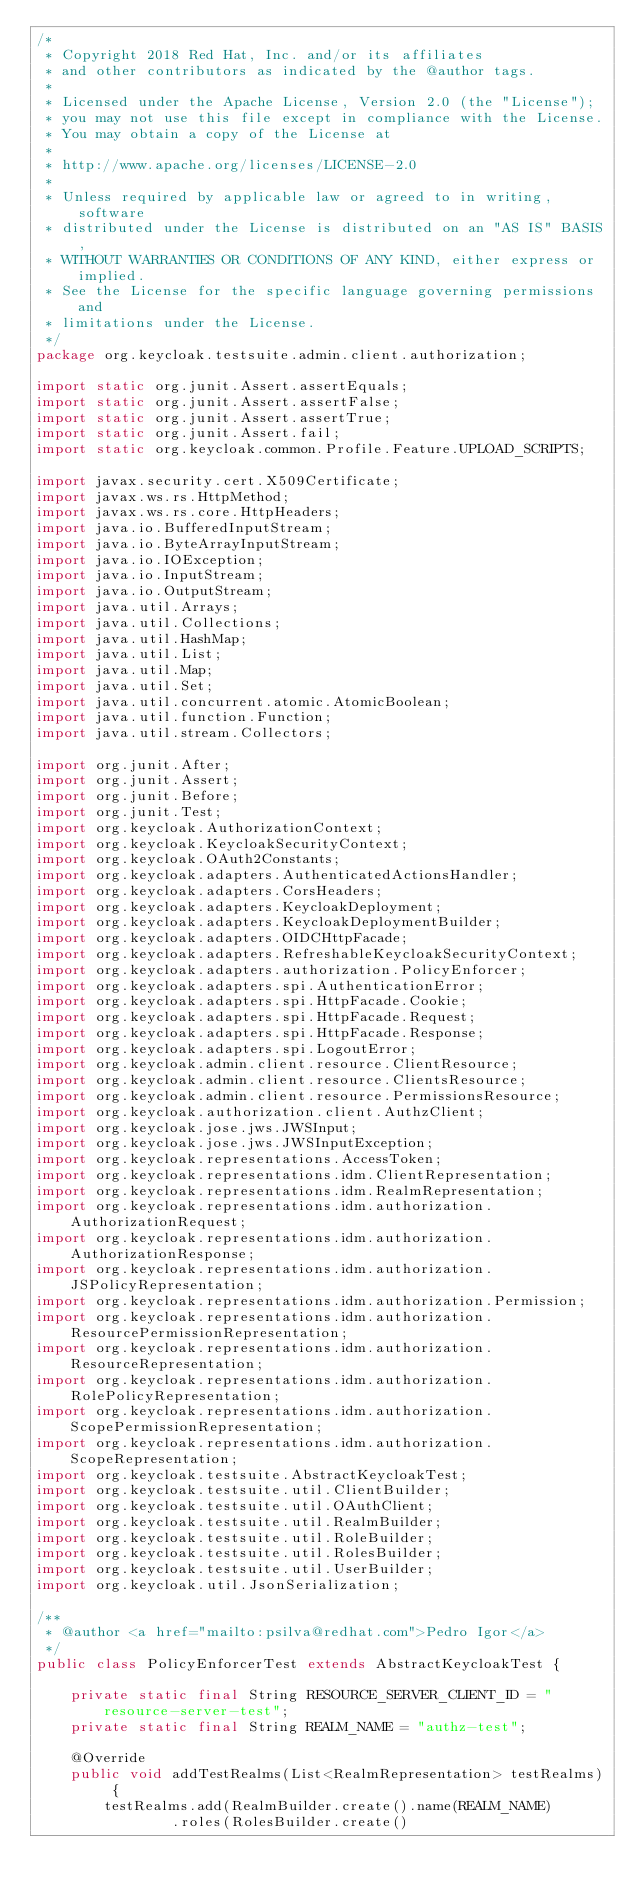Convert code to text. <code><loc_0><loc_0><loc_500><loc_500><_Java_>/*
 * Copyright 2018 Red Hat, Inc. and/or its affiliates
 * and other contributors as indicated by the @author tags.
 *
 * Licensed under the Apache License, Version 2.0 (the "License");
 * you may not use this file except in compliance with the License.
 * You may obtain a copy of the License at
 *
 * http://www.apache.org/licenses/LICENSE-2.0
 *
 * Unless required by applicable law or agreed to in writing, software
 * distributed under the License is distributed on an "AS IS" BASIS,
 * WITHOUT WARRANTIES OR CONDITIONS OF ANY KIND, either express or implied.
 * See the License for the specific language governing permissions and
 * limitations under the License.
 */
package org.keycloak.testsuite.admin.client.authorization;

import static org.junit.Assert.assertEquals;
import static org.junit.Assert.assertFalse;
import static org.junit.Assert.assertTrue;
import static org.junit.Assert.fail;
import static org.keycloak.common.Profile.Feature.UPLOAD_SCRIPTS;

import javax.security.cert.X509Certificate;
import javax.ws.rs.HttpMethod;
import javax.ws.rs.core.HttpHeaders;
import java.io.BufferedInputStream;
import java.io.ByteArrayInputStream;
import java.io.IOException;
import java.io.InputStream;
import java.io.OutputStream;
import java.util.Arrays;
import java.util.Collections;
import java.util.HashMap;
import java.util.List;
import java.util.Map;
import java.util.Set;
import java.util.concurrent.atomic.AtomicBoolean;
import java.util.function.Function;
import java.util.stream.Collectors;

import org.junit.After;
import org.junit.Assert;
import org.junit.Before;
import org.junit.Test;
import org.keycloak.AuthorizationContext;
import org.keycloak.KeycloakSecurityContext;
import org.keycloak.OAuth2Constants;
import org.keycloak.adapters.AuthenticatedActionsHandler;
import org.keycloak.adapters.CorsHeaders;
import org.keycloak.adapters.KeycloakDeployment;
import org.keycloak.adapters.KeycloakDeploymentBuilder;
import org.keycloak.adapters.OIDCHttpFacade;
import org.keycloak.adapters.RefreshableKeycloakSecurityContext;
import org.keycloak.adapters.authorization.PolicyEnforcer;
import org.keycloak.adapters.spi.AuthenticationError;
import org.keycloak.adapters.spi.HttpFacade.Cookie;
import org.keycloak.adapters.spi.HttpFacade.Request;
import org.keycloak.adapters.spi.HttpFacade.Response;
import org.keycloak.adapters.spi.LogoutError;
import org.keycloak.admin.client.resource.ClientResource;
import org.keycloak.admin.client.resource.ClientsResource;
import org.keycloak.admin.client.resource.PermissionsResource;
import org.keycloak.authorization.client.AuthzClient;
import org.keycloak.jose.jws.JWSInput;
import org.keycloak.jose.jws.JWSInputException;
import org.keycloak.representations.AccessToken;
import org.keycloak.representations.idm.ClientRepresentation;
import org.keycloak.representations.idm.RealmRepresentation;
import org.keycloak.representations.idm.authorization.AuthorizationRequest;
import org.keycloak.representations.idm.authorization.AuthorizationResponse;
import org.keycloak.representations.idm.authorization.JSPolicyRepresentation;
import org.keycloak.representations.idm.authorization.Permission;
import org.keycloak.representations.idm.authorization.ResourcePermissionRepresentation;
import org.keycloak.representations.idm.authorization.ResourceRepresentation;
import org.keycloak.representations.idm.authorization.RolePolicyRepresentation;
import org.keycloak.representations.idm.authorization.ScopePermissionRepresentation;
import org.keycloak.representations.idm.authorization.ScopeRepresentation;
import org.keycloak.testsuite.AbstractKeycloakTest;
import org.keycloak.testsuite.util.ClientBuilder;
import org.keycloak.testsuite.util.OAuthClient;
import org.keycloak.testsuite.util.RealmBuilder;
import org.keycloak.testsuite.util.RoleBuilder;
import org.keycloak.testsuite.util.RolesBuilder;
import org.keycloak.testsuite.util.UserBuilder;
import org.keycloak.util.JsonSerialization;

/**
 * @author <a href="mailto:psilva@redhat.com">Pedro Igor</a>
 */
public class PolicyEnforcerTest extends AbstractKeycloakTest {

    private static final String RESOURCE_SERVER_CLIENT_ID = "resource-server-test";
    private static final String REALM_NAME = "authz-test";

    @Override
    public void addTestRealms(List<RealmRepresentation> testRealms) {
        testRealms.add(RealmBuilder.create().name(REALM_NAME)
                .roles(RolesBuilder.create()</code> 